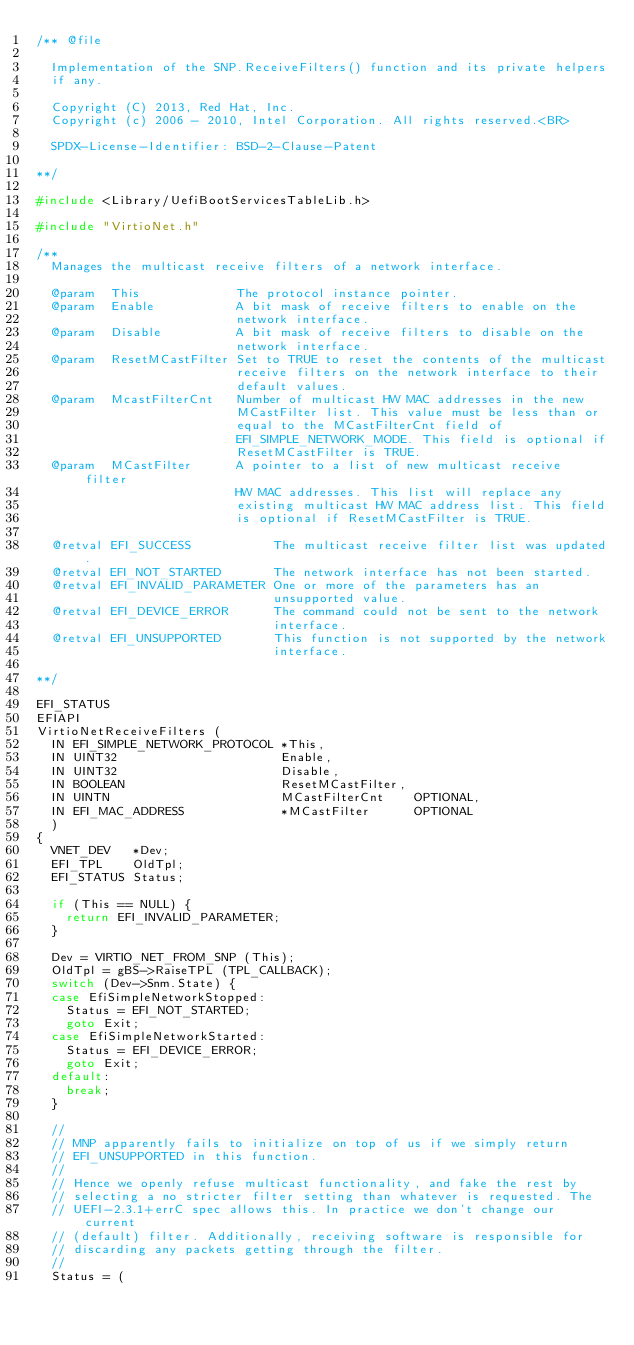<code> <loc_0><loc_0><loc_500><loc_500><_C_>/** @file

  Implementation of the SNP.ReceiveFilters() function and its private helpers
  if any.

  Copyright (C) 2013, Red Hat, Inc.
  Copyright (c) 2006 - 2010, Intel Corporation. All rights reserved.<BR>

  SPDX-License-Identifier: BSD-2-Clause-Patent

**/

#include <Library/UefiBootServicesTableLib.h>

#include "VirtioNet.h"

/**
  Manages the multicast receive filters of a network interface.

  @param  This             The protocol instance pointer.
  @param  Enable           A bit mask of receive filters to enable on the
                           network interface.
  @param  Disable          A bit mask of receive filters to disable on the
                           network interface.
  @param  ResetMCastFilter Set to TRUE to reset the contents of the multicast
                           receive filters on the network interface to their
                           default values.
  @param  McastFilterCnt   Number of multicast HW MAC addresses in the new
                           MCastFilter list. This value must be less than or
                           equal to the MCastFilterCnt field of
                           EFI_SIMPLE_NETWORK_MODE. This field is optional if
                           ResetMCastFilter is TRUE.
  @param  MCastFilter      A pointer to a list of new multicast receive filter
                           HW MAC addresses. This list will replace any
                           existing multicast HW MAC address list. This field
                           is optional if ResetMCastFilter is TRUE.

  @retval EFI_SUCCESS           The multicast receive filter list was updated.
  @retval EFI_NOT_STARTED       The network interface has not been started.
  @retval EFI_INVALID_PARAMETER One or more of the parameters has an
                                unsupported value.
  @retval EFI_DEVICE_ERROR      The command could not be sent to the network
                                interface.
  @retval EFI_UNSUPPORTED       This function is not supported by the network
                                interface.

**/

EFI_STATUS
EFIAPI
VirtioNetReceiveFilters (
  IN EFI_SIMPLE_NETWORK_PROTOCOL *This,
  IN UINT32                      Enable,
  IN UINT32                      Disable,
  IN BOOLEAN                     ResetMCastFilter,
  IN UINTN                       MCastFilterCnt    OPTIONAL,
  IN EFI_MAC_ADDRESS             *MCastFilter      OPTIONAL
  )
{
  VNET_DEV   *Dev;
  EFI_TPL    OldTpl;
  EFI_STATUS Status;

  if (This == NULL) {
    return EFI_INVALID_PARAMETER;
  }

  Dev = VIRTIO_NET_FROM_SNP (This);
  OldTpl = gBS->RaiseTPL (TPL_CALLBACK);
  switch (Dev->Snm.State) {
  case EfiSimpleNetworkStopped:
    Status = EFI_NOT_STARTED;
    goto Exit;
  case EfiSimpleNetworkStarted:
    Status = EFI_DEVICE_ERROR;
    goto Exit;
  default:
    break;
  }

  //
  // MNP apparently fails to initialize on top of us if we simply return
  // EFI_UNSUPPORTED in this function.
  //
  // Hence we openly refuse multicast functionality, and fake the rest by
  // selecting a no stricter filter setting than whatever is requested. The
  // UEFI-2.3.1+errC spec allows this. In practice we don't change our current
  // (default) filter. Additionally, receiving software is responsible for
  // discarding any packets getting through the filter.
  //
  Status = (</code> 